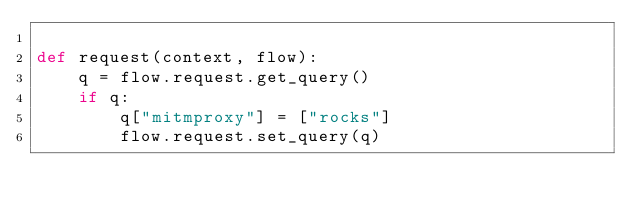<code> <loc_0><loc_0><loc_500><loc_500><_Python_>
def request(context, flow):
    q = flow.request.get_query()
    if q:
        q["mitmproxy"] = ["rocks"]
        flow.request.set_query(q)</code> 